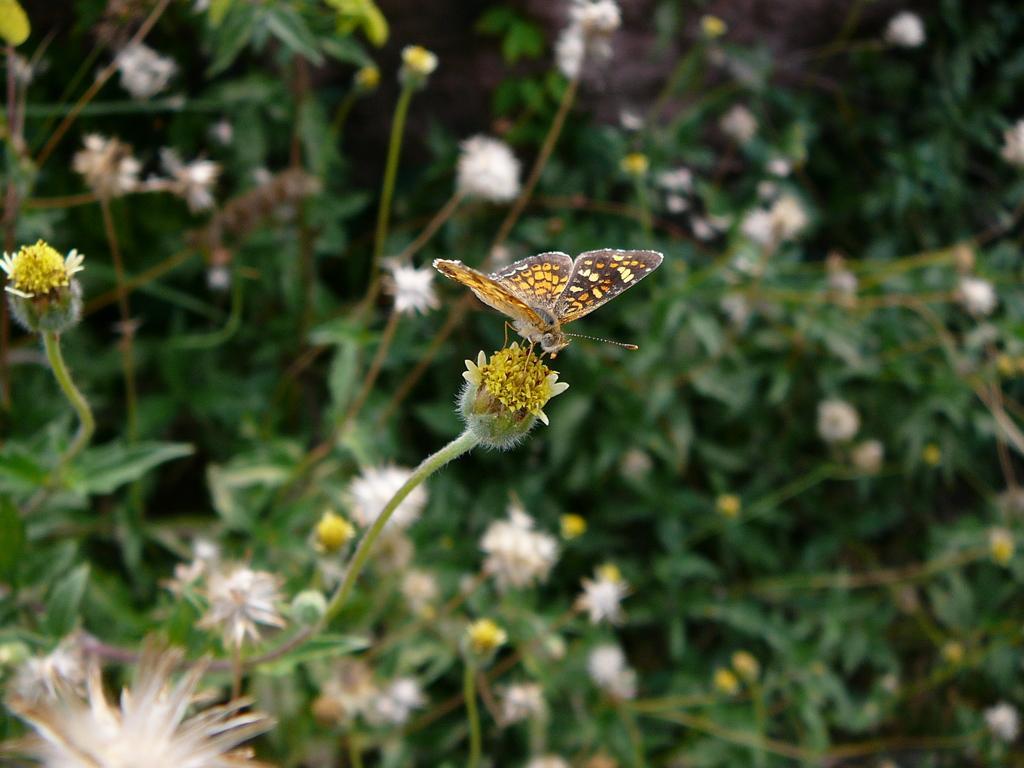How would you summarize this image in a sentence or two? In this image in the front there is a butterfly sitting on the flower. In the background there are flowers and leaves. 